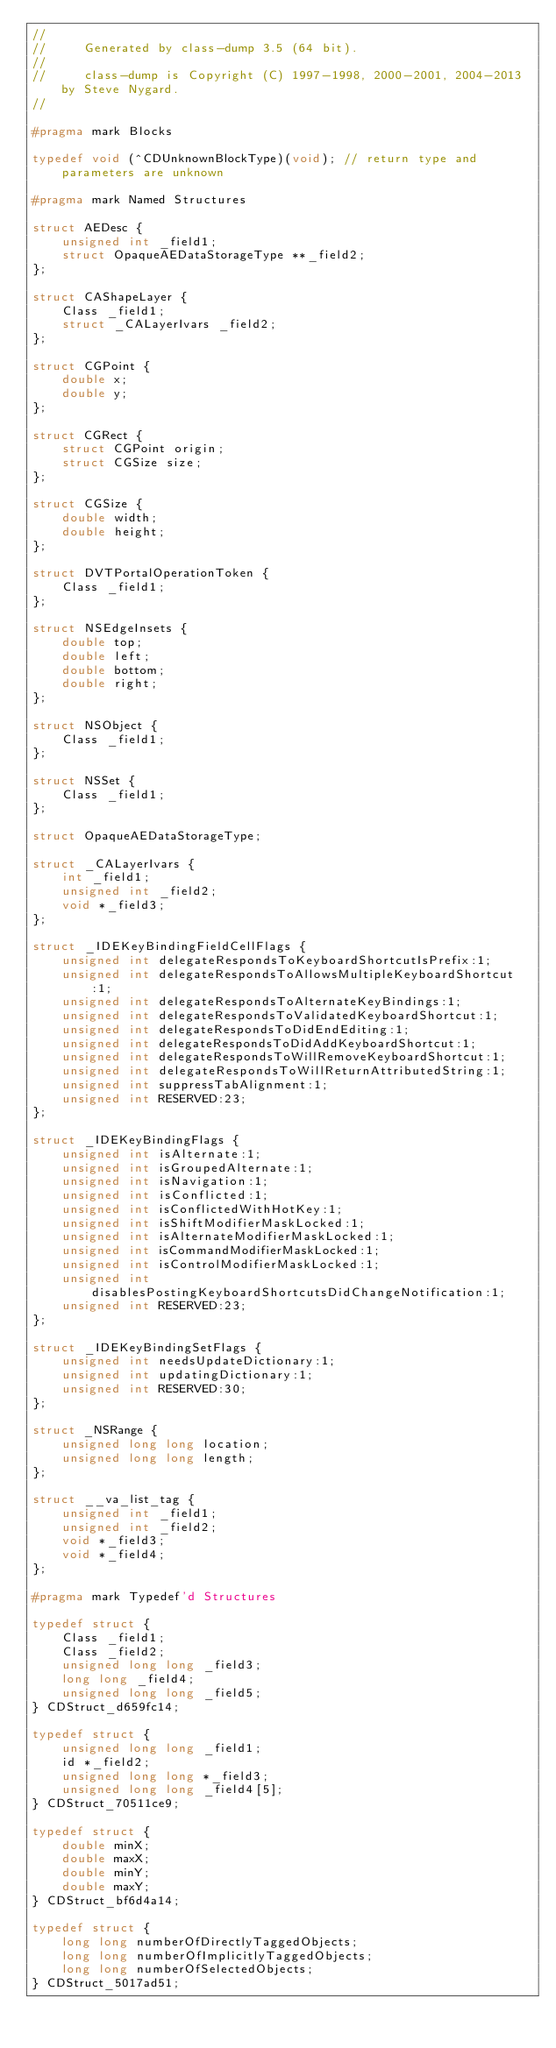<code> <loc_0><loc_0><loc_500><loc_500><_C_>//
//     Generated by class-dump 3.5 (64 bit).
//
//     class-dump is Copyright (C) 1997-1998, 2000-2001, 2004-2013 by Steve Nygard.
//

#pragma mark Blocks

typedef void (^CDUnknownBlockType)(void); // return type and parameters are unknown

#pragma mark Named Structures

struct AEDesc {
    unsigned int _field1;
    struct OpaqueAEDataStorageType **_field2;
};

struct CAShapeLayer {
    Class _field1;
    struct _CALayerIvars _field2;
};

struct CGPoint {
    double x;
    double y;
};

struct CGRect {
    struct CGPoint origin;
    struct CGSize size;
};

struct CGSize {
    double width;
    double height;
};

struct DVTPortalOperationToken {
    Class _field1;
};

struct NSEdgeInsets {
    double top;
    double left;
    double bottom;
    double right;
};

struct NSObject {
    Class _field1;
};

struct NSSet {
    Class _field1;
};

struct OpaqueAEDataStorageType;

struct _CALayerIvars {
    int _field1;
    unsigned int _field2;
    void *_field3;
};

struct _IDEKeyBindingFieldCellFlags {
    unsigned int delegateRespondsToKeyboardShortcutIsPrefix:1;
    unsigned int delegateRespondsToAllowsMultipleKeyboardShortcut:1;
    unsigned int delegateRespondsToAlternateKeyBindings:1;
    unsigned int delegateRespondsToValidatedKeyboardShortcut:1;
    unsigned int delegateRespondsToDidEndEditing:1;
    unsigned int delegateRespondsToDidAddKeyboardShortcut:1;
    unsigned int delegateRespondsToWillRemoveKeyboardShortcut:1;
    unsigned int delegateRespondsToWillReturnAttributedString:1;
    unsigned int suppressTabAlignment:1;
    unsigned int RESERVED:23;
};

struct _IDEKeyBindingFlags {
    unsigned int isAlternate:1;
    unsigned int isGroupedAlternate:1;
    unsigned int isNavigation:1;
    unsigned int isConflicted:1;
    unsigned int isConflictedWithHotKey:1;
    unsigned int isShiftModifierMaskLocked:1;
    unsigned int isAlternateModifierMaskLocked:1;
    unsigned int isCommandModifierMaskLocked:1;
    unsigned int isControlModifierMaskLocked:1;
    unsigned int disablesPostingKeyboardShortcutsDidChangeNotification:1;
    unsigned int RESERVED:23;
};

struct _IDEKeyBindingSetFlags {
    unsigned int needsUpdateDictionary:1;
    unsigned int updatingDictionary:1;
    unsigned int RESERVED:30;
};

struct _NSRange {
    unsigned long long location;
    unsigned long long length;
};

struct __va_list_tag {
    unsigned int _field1;
    unsigned int _field2;
    void *_field3;
    void *_field4;
};

#pragma mark Typedef'd Structures

typedef struct {
    Class _field1;
    Class _field2;
    unsigned long long _field3;
    long long _field4;
    unsigned long long _field5;
} CDStruct_d659fc14;

typedef struct {
    unsigned long long _field1;
    id *_field2;
    unsigned long long *_field3;
    unsigned long long _field4[5];
} CDStruct_70511ce9;

typedef struct {
    double minX;
    double maxX;
    double minY;
    double maxY;
} CDStruct_bf6d4a14;

typedef struct {
    long long numberOfDirectlyTaggedObjects;
    long long numberOfImplicitlyTaggedObjects;
    long long numberOfSelectedObjects;
} CDStruct_5017ad51;

</code> 